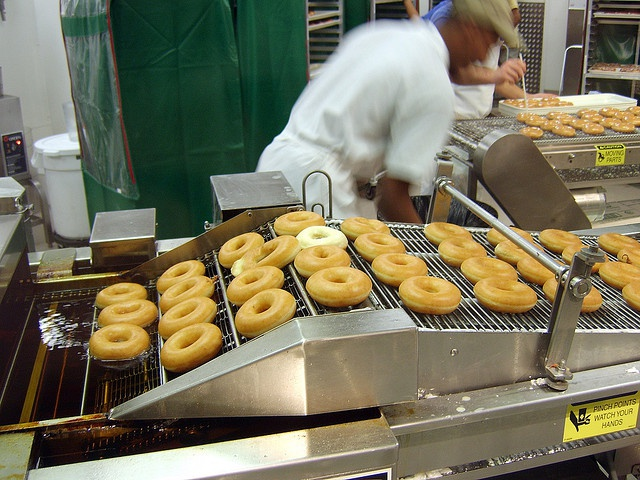Describe the objects in this image and their specific colors. I can see people in purple, lightgray, darkgray, and maroon tones, donut in purple, tan, khaki, and orange tones, people in purple, darkgray, gray, lightgray, and tan tones, donut in purple, tan, olive, maroon, and orange tones, and donut in purple, tan, khaki, orange, and olive tones in this image. 